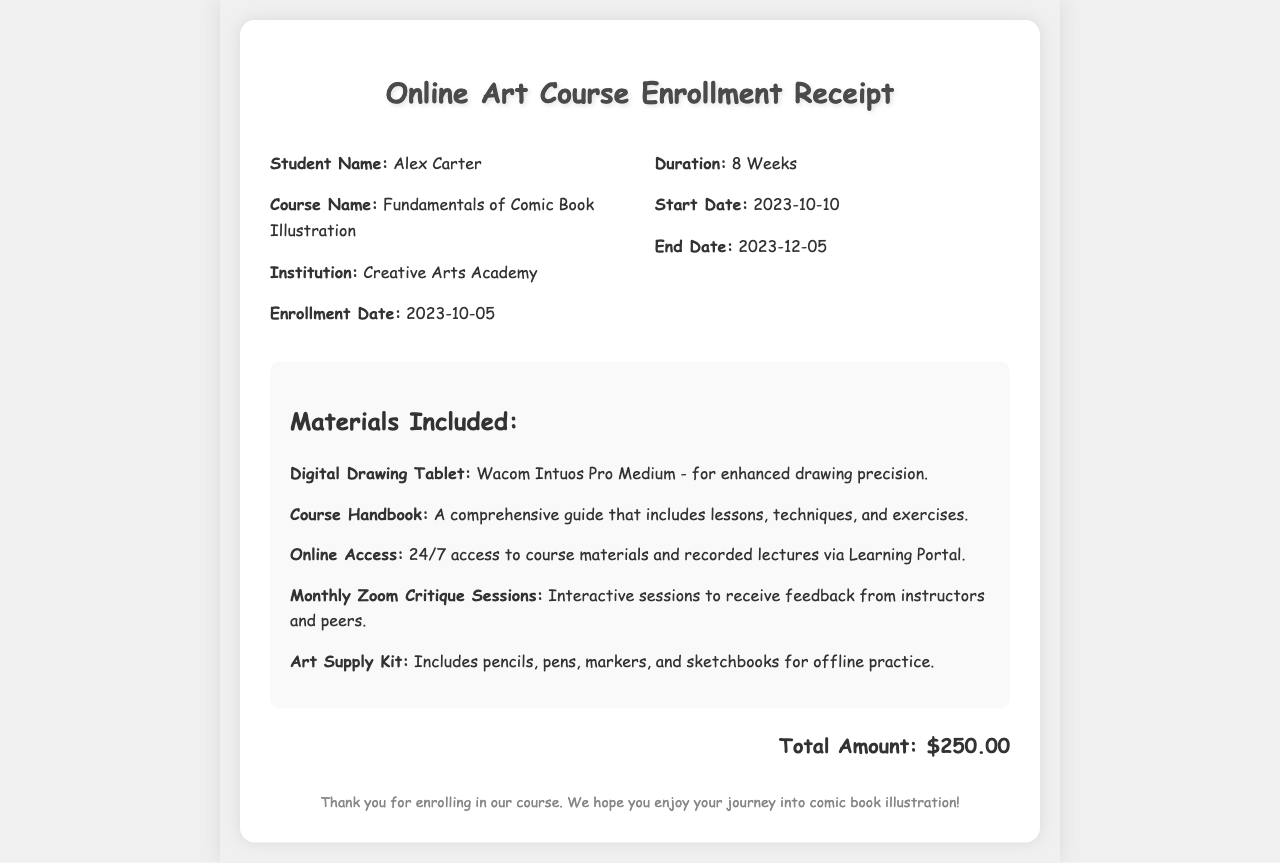What is the course name? The course name is explicitly mentioned in the document under the course details.
Answer: Fundamentals of Comic Book Illustration What is the duration of the course? The duration is indicated in the details section of the receipt.
Answer: 8 Weeks What is the enrollment date? The enrollment date is provided in the student information section of the receipt.
Answer: 2023-10-05 Who is the student? The student's name is clearly listed at the beginning of the receipt.
Answer: Alex Carter When does the course start? The start date is mentioned in the duration section of the receipt.
Answer: 2023-10-10 What materials are included? The receipt lists various materials under the materials included section.
Answer: Digital Drawing Tablet, Course Handbook, Online Access, Monthly Zoom Critique Sessions, Art Supply Kit What is the total amount? The total amount is specifically detailed in the total section of the receipt.
Answer: $250.00 What institution is offering the course? The name of the institution is provided in the course details section.
Answer: Creative Arts Academy When does the course end? The end date is mentioned in the duration section of the receipt.
Answer: 2023-12-05 